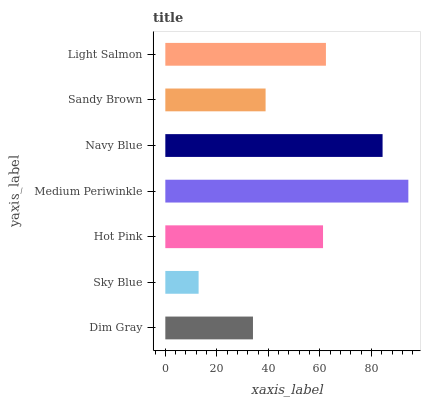Is Sky Blue the minimum?
Answer yes or no. Yes. Is Medium Periwinkle the maximum?
Answer yes or no. Yes. Is Hot Pink the minimum?
Answer yes or no. No. Is Hot Pink the maximum?
Answer yes or no. No. Is Hot Pink greater than Sky Blue?
Answer yes or no. Yes. Is Sky Blue less than Hot Pink?
Answer yes or no. Yes. Is Sky Blue greater than Hot Pink?
Answer yes or no. No. Is Hot Pink less than Sky Blue?
Answer yes or no. No. Is Hot Pink the high median?
Answer yes or no. Yes. Is Hot Pink the low median?
Answer yes or no. Yes. Is Sandy Brown the high median?
Answer yes or no. No. Is Light Salmon the low median?
Answer yes or no. No. 